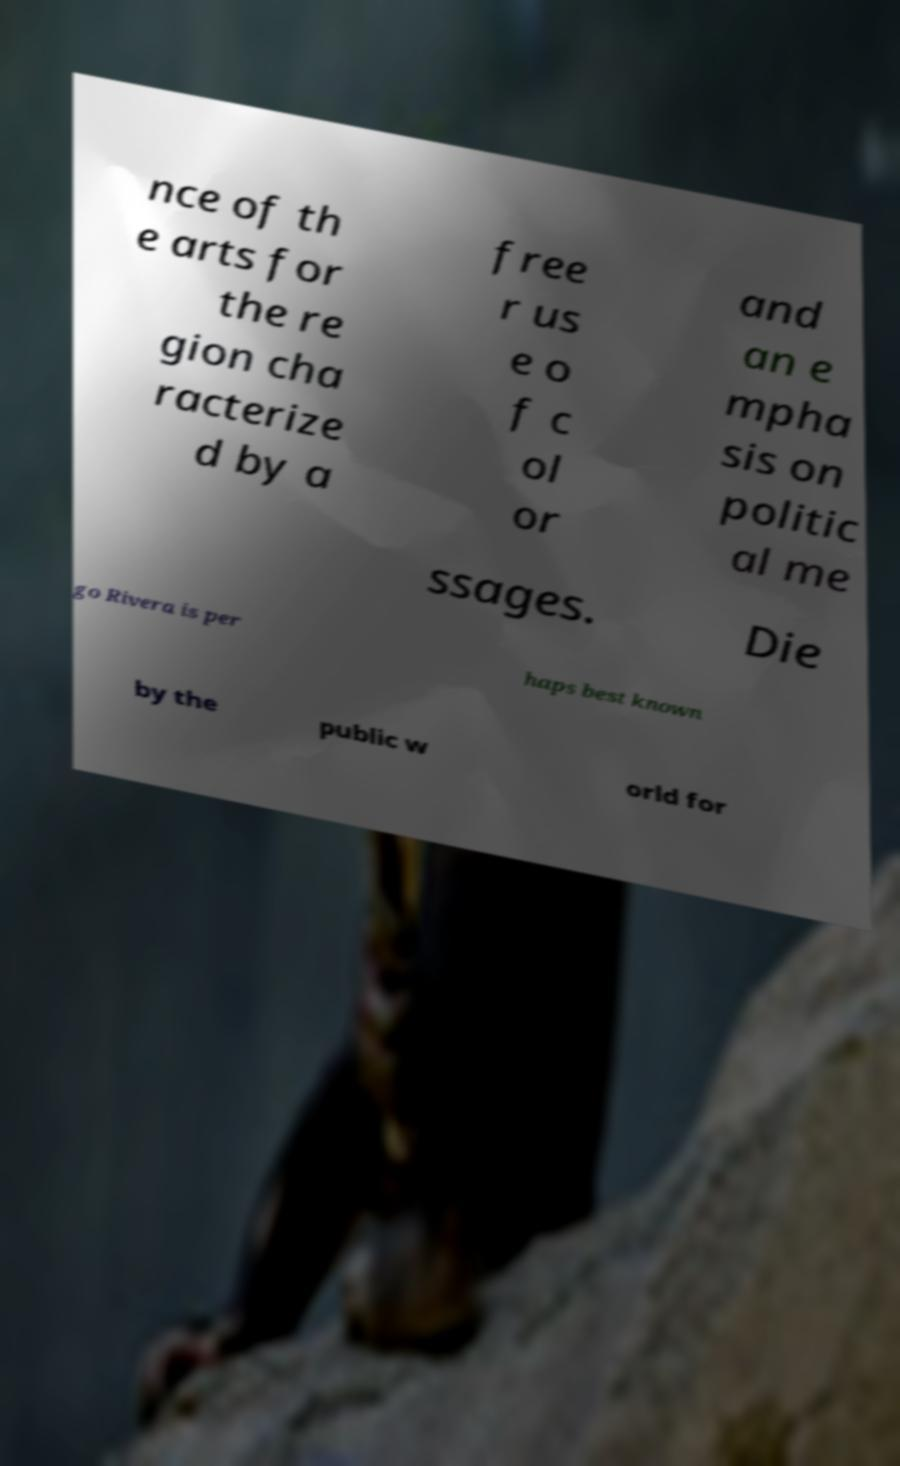There's text embedded in this image that I need extracted. Can you transcribe it verbatim? nce of th e arts for the re gion cha racterize d by a free r us e o f c ol or and an e mpha sis on politic al me ssages. Die go Rivera is per haps best known by the public w orld for 